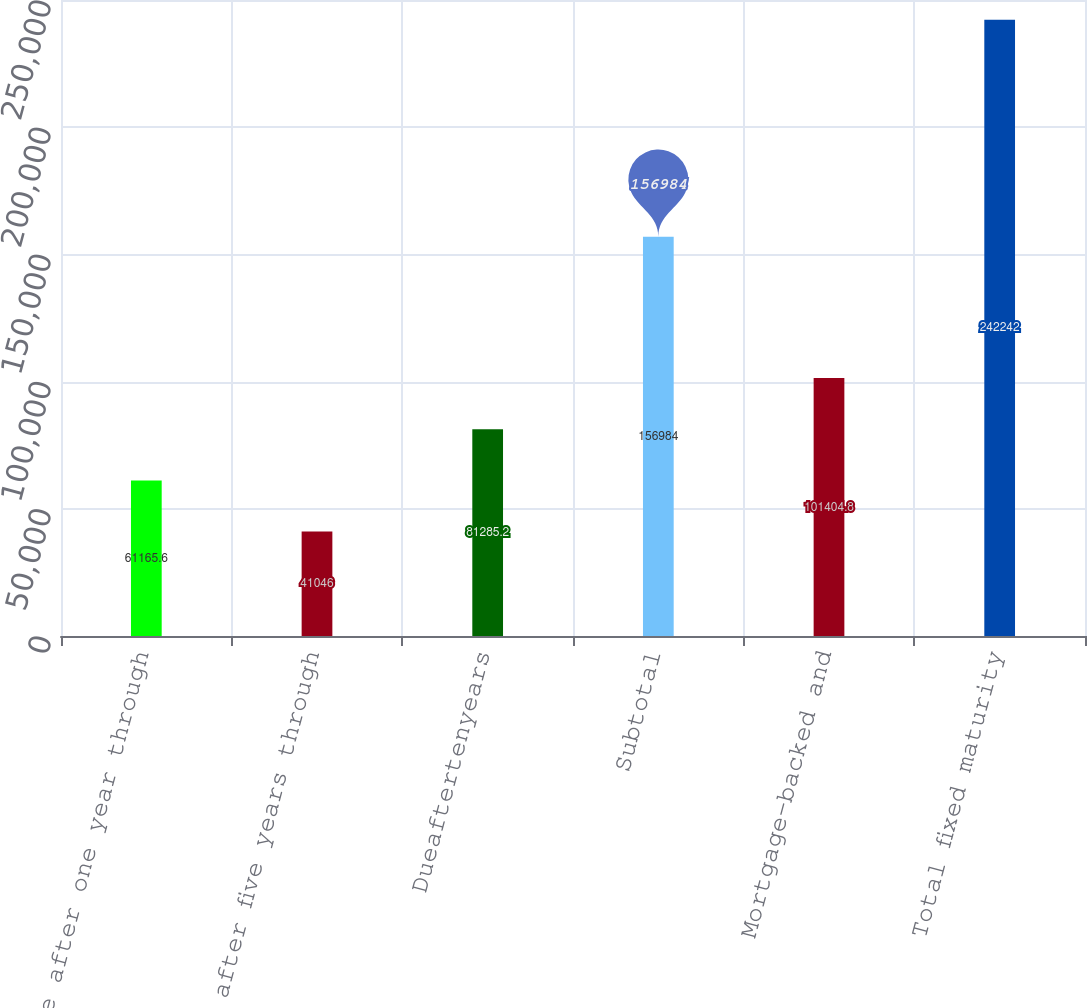Convert chart. <chart><loc_0><loc_0><loc_500><loc_500><bar_chart><fcel>Due after one year through<fcel>Due after five years through<fcel>Dueaftertenyears<fcel>Subtotal<fcel>Mortgage-backed and<fcel>Total fixed maturity<nl><fcel>61165.6<fcel>41046<fcel>81285.2<fcel>156984<fcel>101405<fcel>242242<nl></chart> 